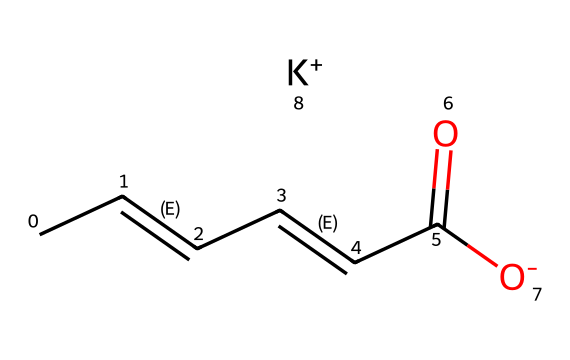How many carbon atoms are in potassium sorbate? In the SMILES representation, the carbon atoms can be counted from the formula. There are a total of 6 carbon atoms present, as each 'C' represents one carbon atom.
Answer: six What is the charge of the potassium ion in this structure? The potassium ion is represented as [K+], which indicates that it carries a positive charge.
Answer: positive What type of functional group is present in potassium sorbate? The presence of (C(=O)[O-]) indicates there is a carboxylate group in the structure, which is a characteristic of carboxylic acids and their salts.
Answer: carboxylate How many double bonds are present in the structure of potassium sorbate? By examining the structure, there are three double bonds indicated by the 'C=C' sequences, which shows the presence of carbon double bonds.
Answer: three What is the significance of potassium sorbate in art preservation? Potassium sorbate is effective in inhibiting microbial growth, which helps in preserving the integrity of paints and other artistic materials from degradation.
Answer: inhibits microbial growth Is potassium sorbate soluble in water? Potassium sorbate is known to be soluble in water, allowing it to mix easily and be used in various aqueous solutions for preservation purposes.
Answer: soluble 